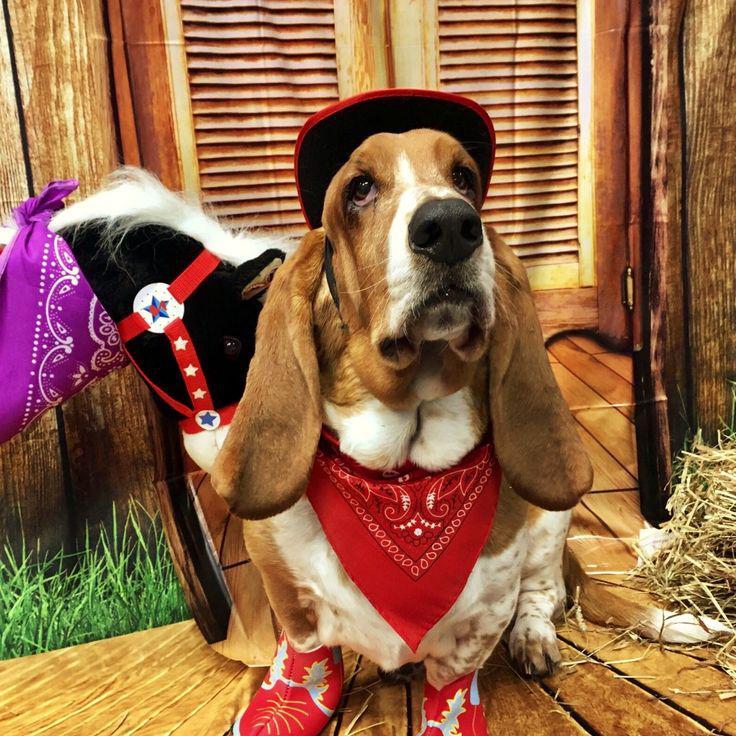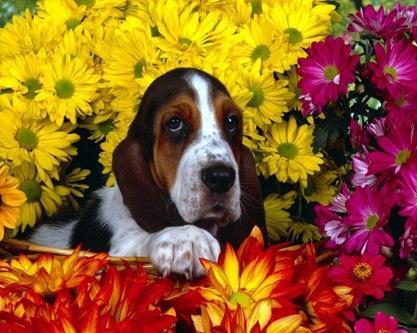The first image is the image on the left, the second image is the image on the right. Examine the images to the left and right. Is the description "In one of the images, a basset hound is among colorful yellow leaves" accurate? Answer yes or no. No. The first image is the image on the left, the second image is the image on the right. Given the left and right images, does the statement "There are three hounds in the right image." hold true? Answer yes or no. No. 